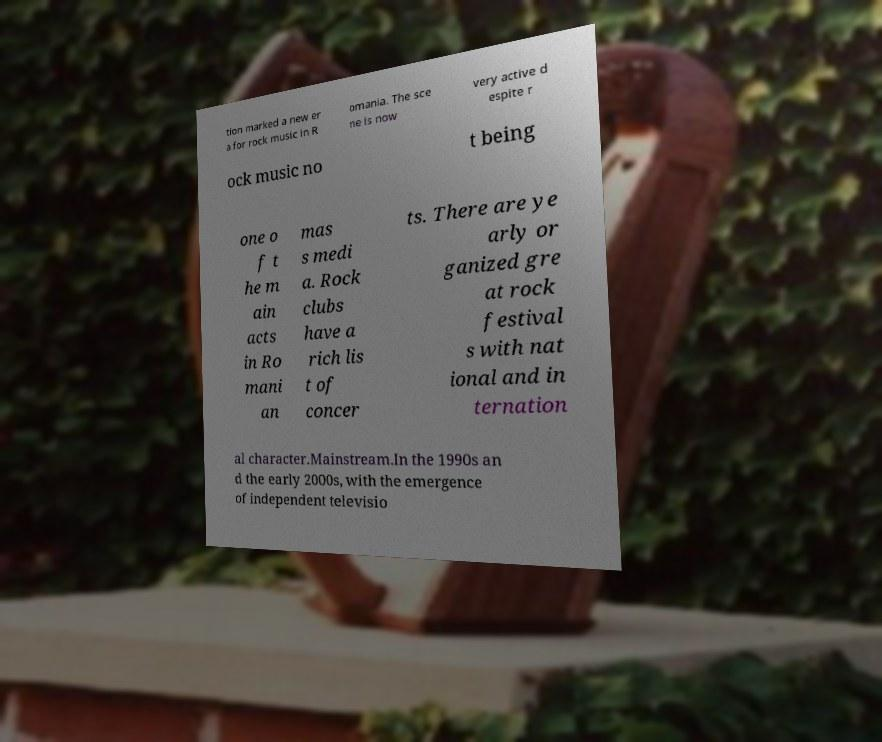What messages or text are displayed in this image? I need them in a readable, typed format. tion marked a new er a for rock music in R omania. The sce ne is now very active d espite r ock music no t being one o f t he m ain acts in Ro mani an mas s medi a. Rock clubs have a rich lis t of concer ts. There are ye arly or ganized gre at rock festival s with nat ional and in ternation al character.Mainstream.In the 1990s an d the early 2000s, with the emergence of independent televisio 